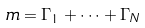Convert formula to latex. <formula><loc_0><loc_0><loc_500><loc_500>m = \Gamma _ { 1 } + \cdots + \Gamma _ { N }</formula> 